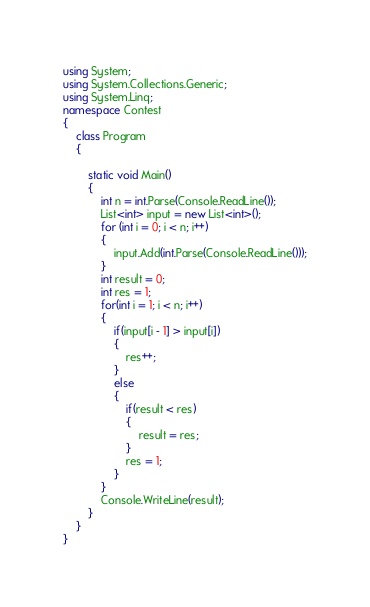<code> <loc_0><loc_0><loc_500><loc_500><_C#_>using System;
using System.Collections.Generic;
using System.Linq;
namespace Contest
{
    class Program
    {

        static void Main()
        {
            int n = int.Parse(Console.ReadLine());
            List<int> input = new List<int>();
            for (int i = 0; i < n; i++)
            {
                input.Add(int.Parse(Console.ReadLine()));
            }
            int result = 0;
            int res = 1;
            for(int i = 1; i < n; i++)
            {
                if(input[i - 1] > input[i])
                {
                    res++;
                }
                else
                {
                    if(result < res)
                    {
                        result = res;
                    }
                    res = 1;
                }
            }
            Console.WriteLine(result);
        }
    }
}
</code> 